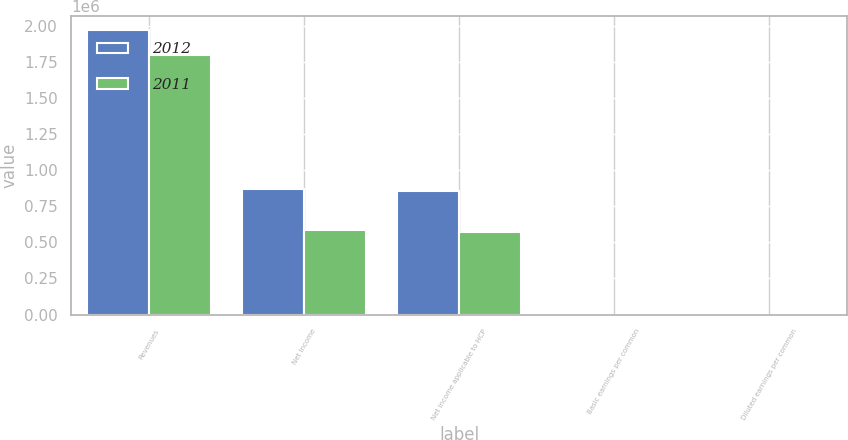<chart> <loc_0><loc_0><loc_500><loc_500><stacked_bar_chart><ecel><fcel>Revenues<fcel>Net income<fcel>Net income applicable to HCP<fcel>Basic earnings per common<fcel>Diluted earnings per common<nl><fcel>2012<fcel>1.9663e+06<fcel>870802<fcel>856500<fcel>1.88<fcel>1.88<nl><fcel>2011<fcel>1.79802e+06<fcel>584361<fcel>568758<fcel>1.3<fcel>1.29<nl></chart> 